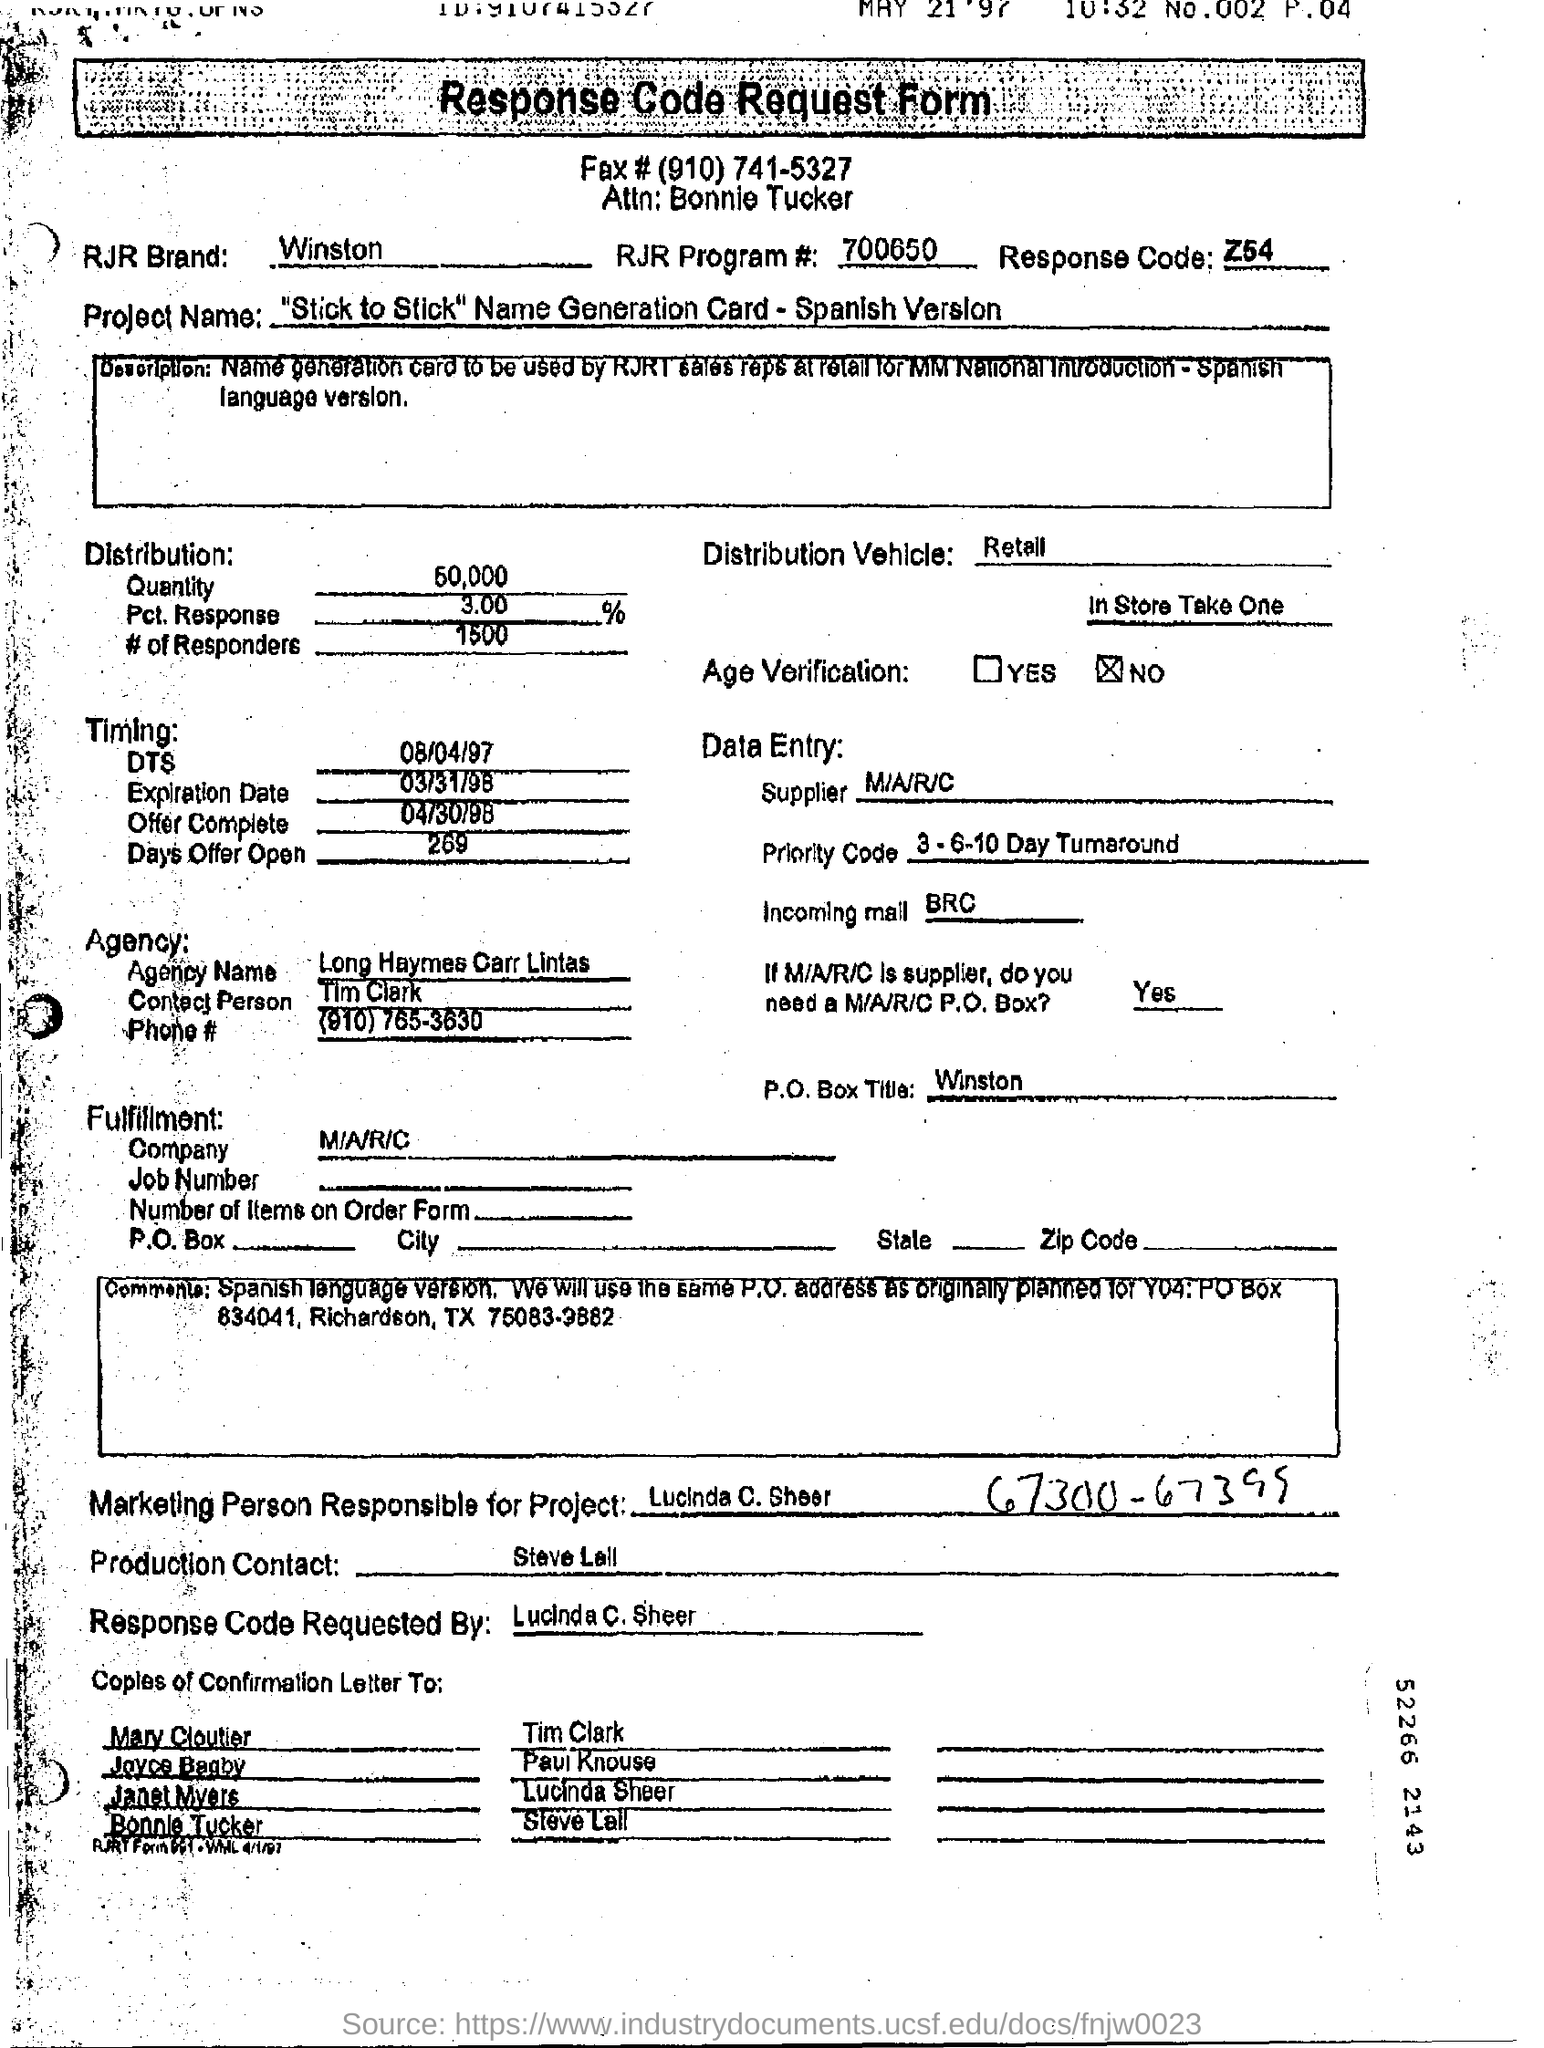What is RJR Brand Name in this form ?
Your answer should be compact. Winston. What is the RJR Program Number of this form ?
Provide a succinct answer. 700650. Who is the marketing person responsible for this project ?
Make the answer very short. Lucinda C. Sheer. What is the response code assigned ?
Provide a short and direct response. Z54. What is the Quantity of distribution ?
Offer a terse response. 50,000. 